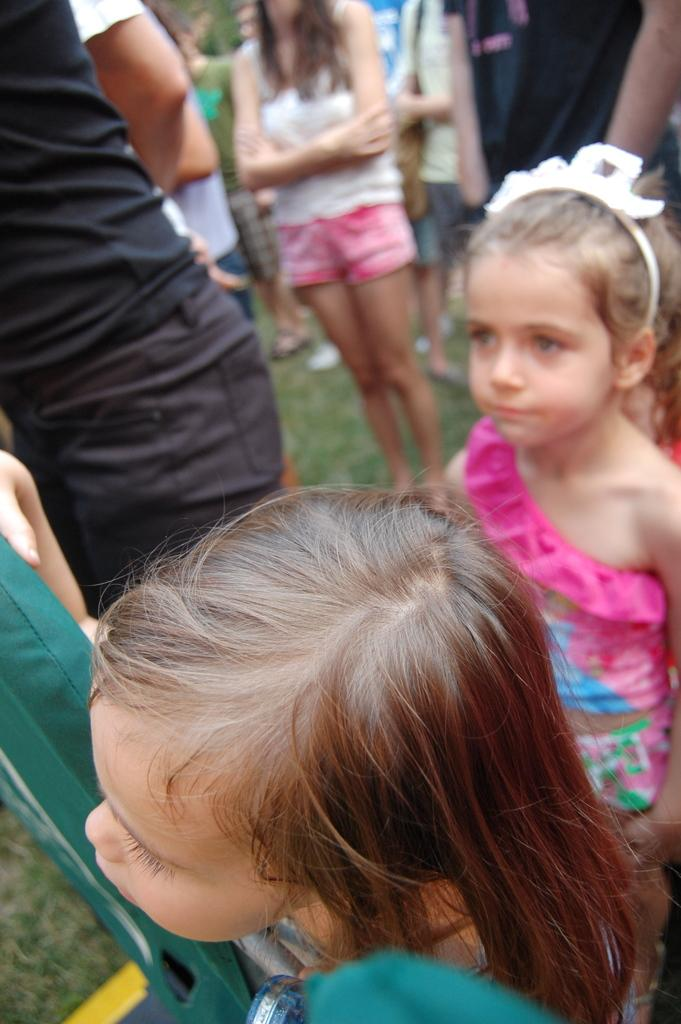What can be seen in the image in terms of human presence? There are people standing in the image. Can you describe the gender of the people in the image? There are girls in the image. What type of surface is visible under the people's feet? Grass is present on the ground in the image. What type of wing can be seen on the owl in the image? There is no owl present in the image, so no wings can be observed. 